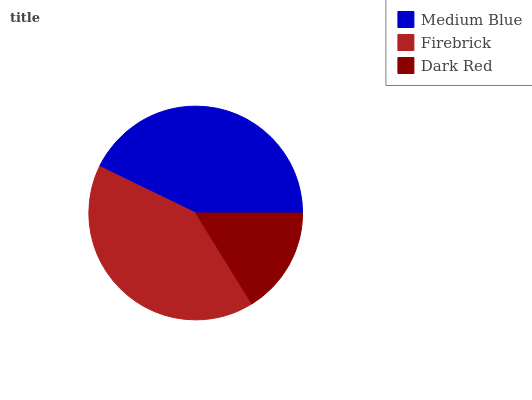Is Dark Red the minimum?
Answer yes or no. Yes. Is Medium Blue the maximum?
Answer yes or no. Yes. Is Firebrick the minimum?
Answer yes or no. No. Is Firebrick the maximum?
Answer yes or no. No. Is Medium Blue greater than Firebrick?
Answer yes or no. Yes. Is Firebrick less than Medium Blue?
Answer yes or no. Yes. Is Firebrick greater than Medium Blue?
Answer yes or no. No. Is Medium Blue less than Firebrick?
Answer yes or no. No. Is Firebrick the high median?
Answer yes or no. Yes. Is Firebrick the low median?
Answer yes or no. Yes. Is Dark Red the high median?
Answer yes or no. No. Is Dark Red the low median?
Answer yes or no. No. 